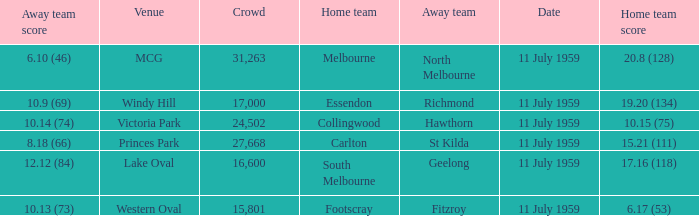How many points does footscray score as the home side? 6.17 (53). 